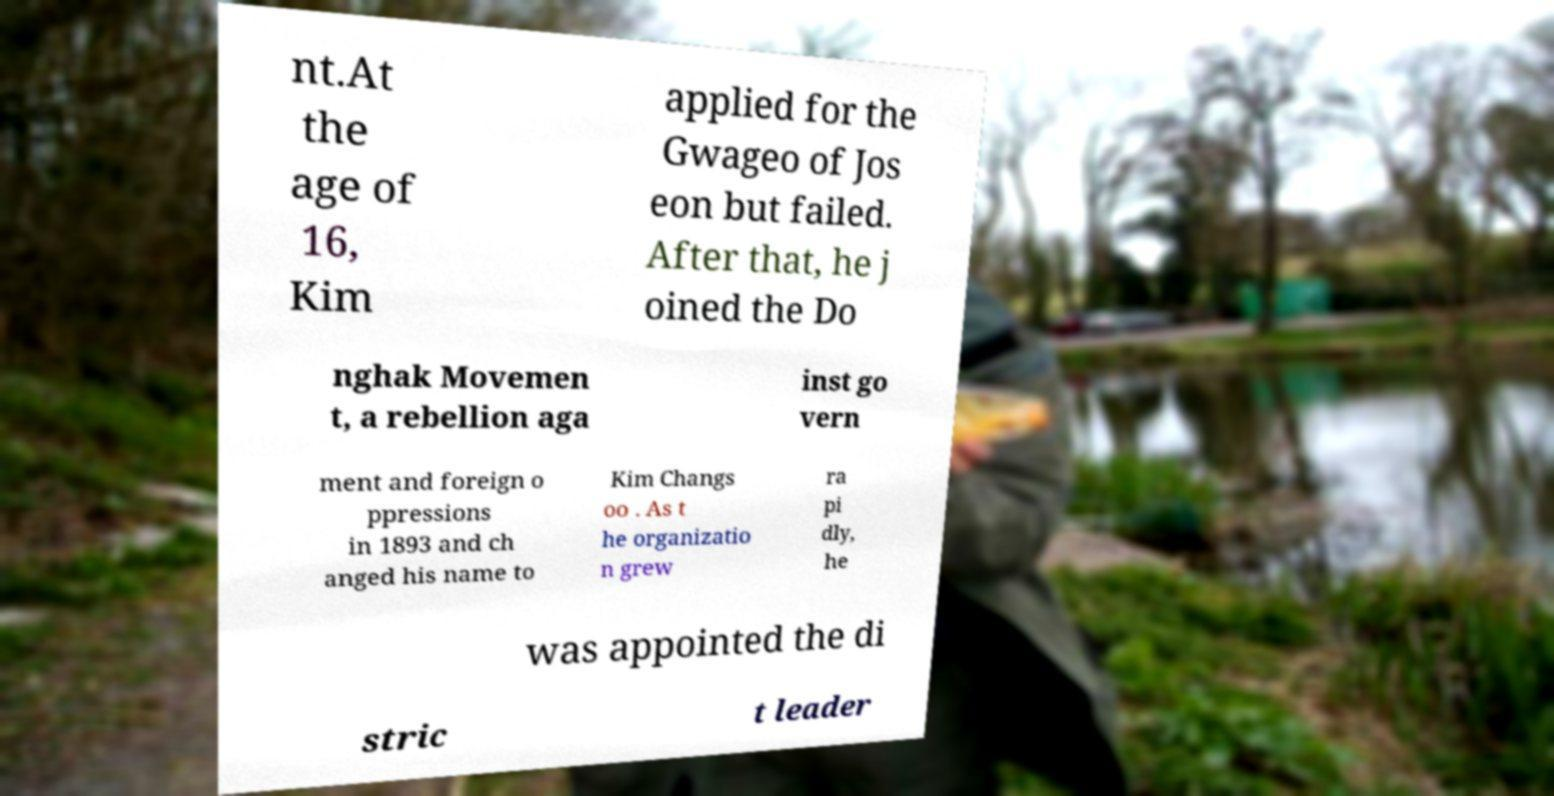Please identify and transcribe the text found in this image. nt.At the age of 16, Kim applied for the Gwageo of Jos eon but failed. After that, he j oined the Do nghak Movemen t, a rebellion aga inst go vern ment and foreign o ppressions in 1893 and ch anged his name to Kim Changs oo . As t he organizatio n grew ra pi dly, he was appointed the di stric t leader 